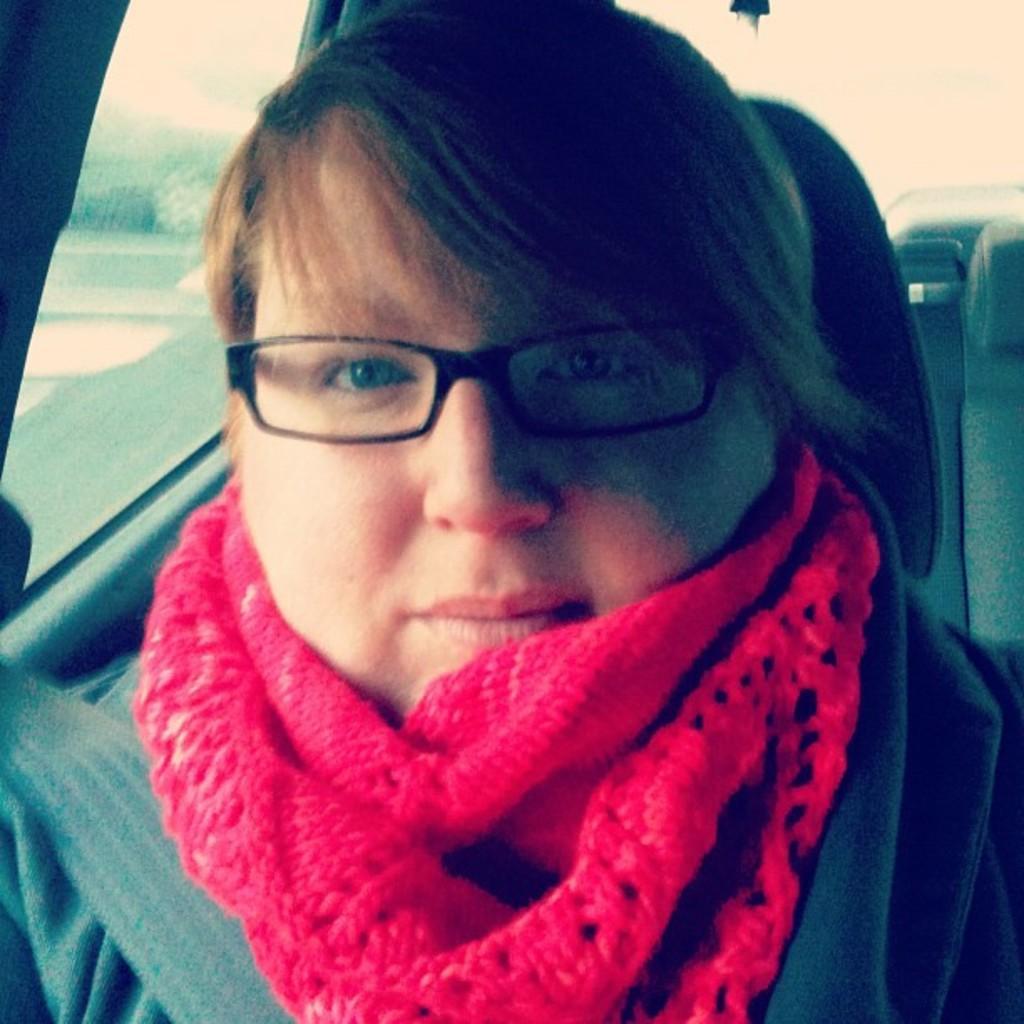Describe this image in one or two sentences. In this image there is one woman who is sitting in a vehicle, and in the background there are some plants. 